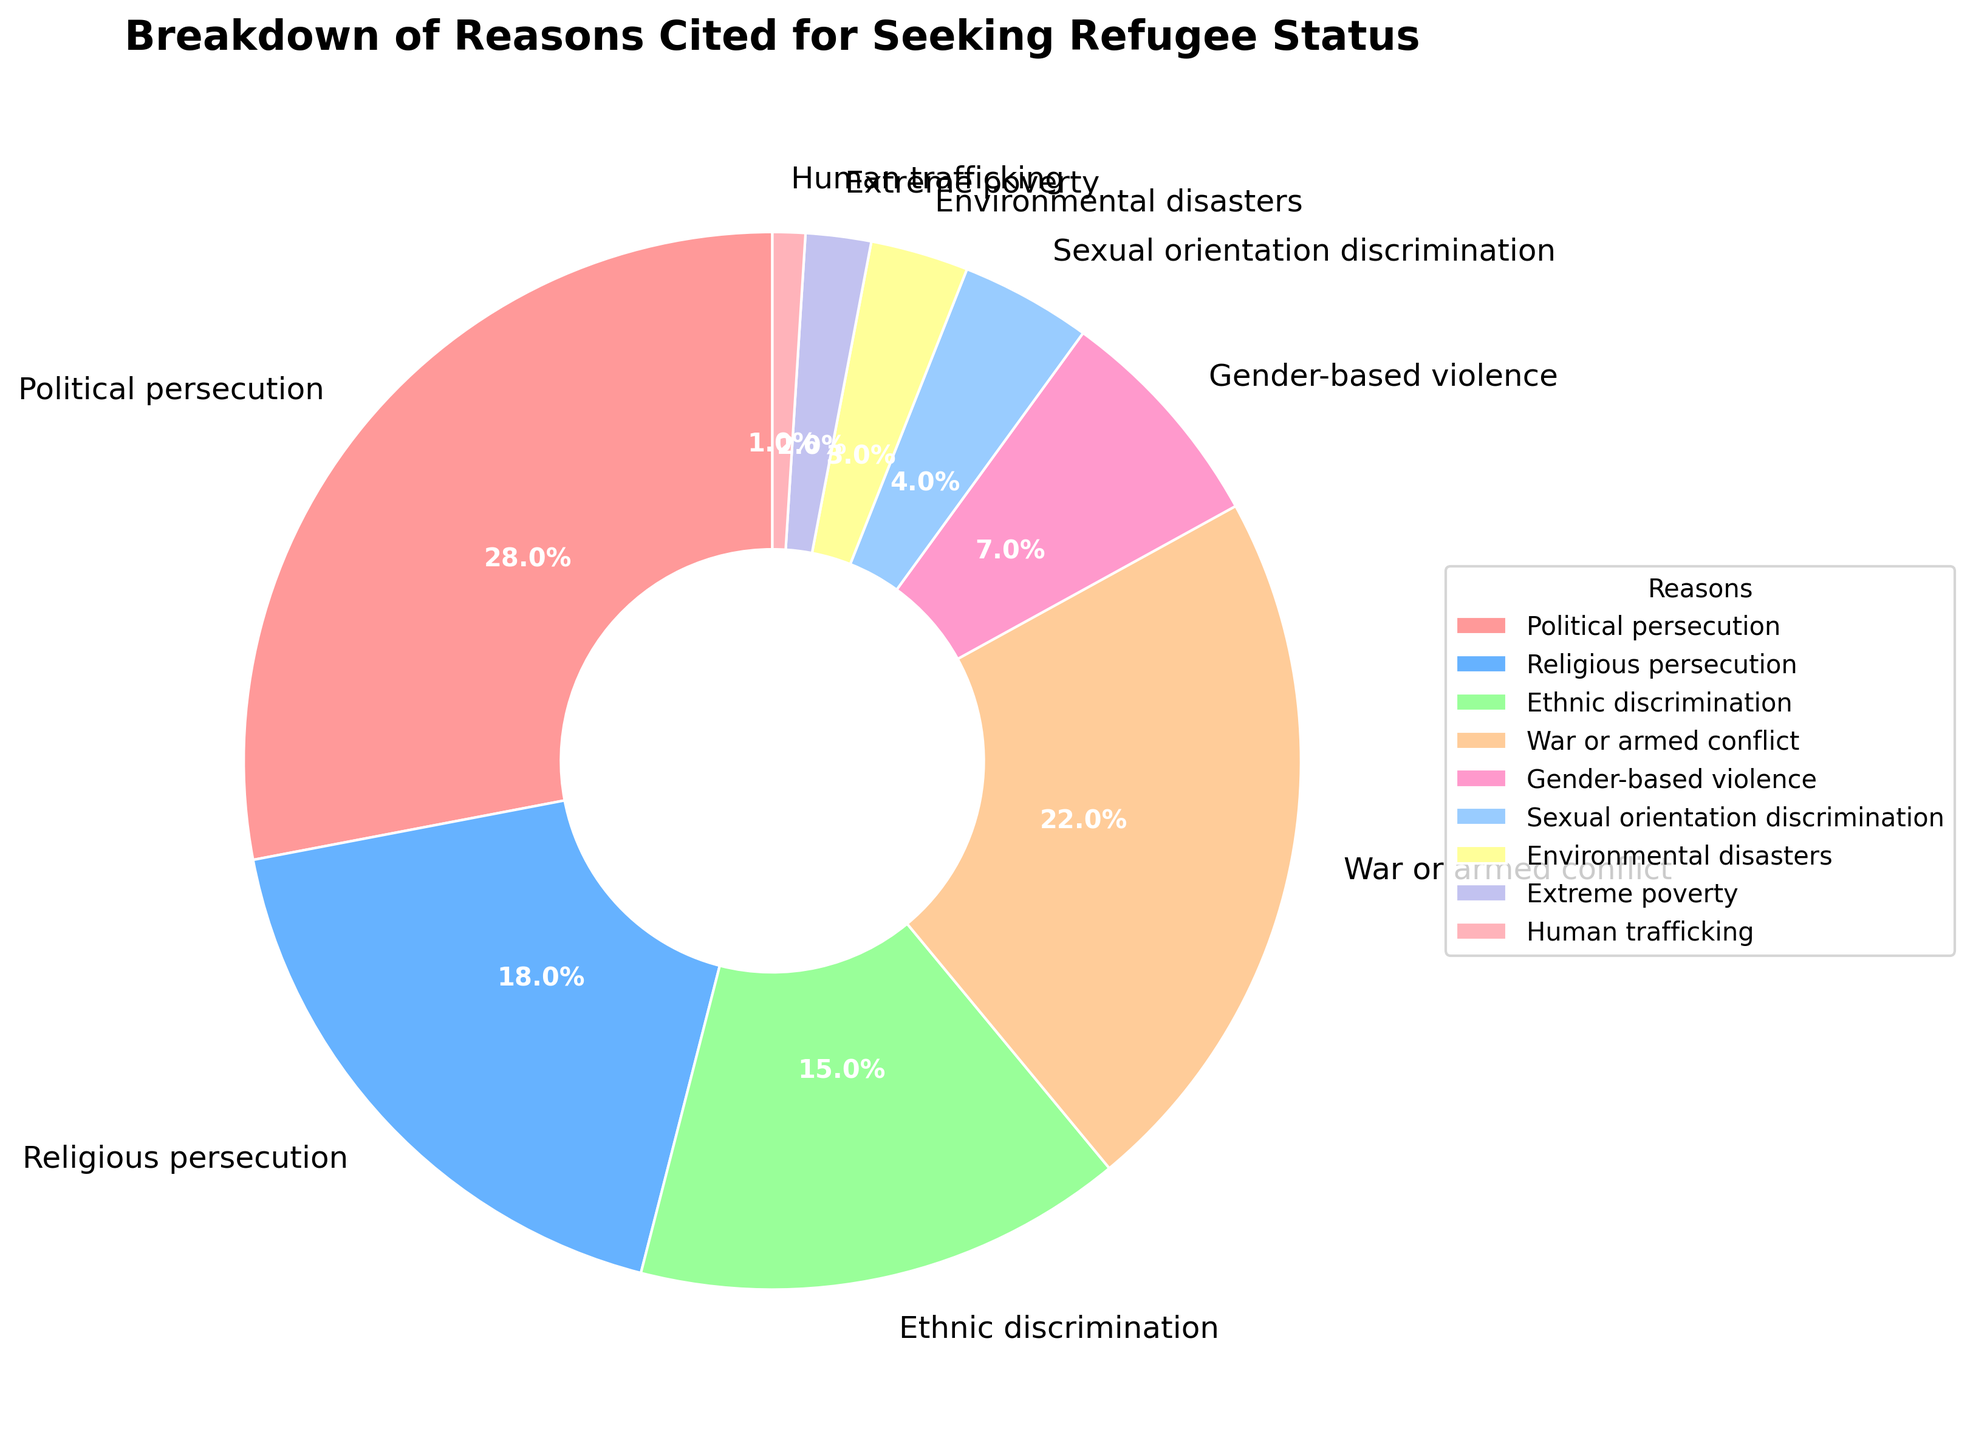Which reason is cited the most for seeking refugee status? From the pie chart, Political persecution has the largest percentage share, accounting for 28%
Answer: Political persecution What percentage of refugees cited war or armed conflict? The pie chart shows that the segment for war or armed conflict is labeled with 22%
Answer: 22% How does the percentage for religious persecution compare to ethnic discrimination? According to the pie chart, religious persecution accounts for 18%, which is higher than ethnic discrimination at 15%
Answer: Religious persecution is higher What is the total percentage for political and religious persecution combined? Summing up the percentages for political persecution (28%) and religious persecution (18%) gives us 28 + 18 = 46%
Answer: 46% Are there more refugees citing environmental disasters or extreme poverty? From the pie chart, environmental disasters account for 3% while extreme poverty accounts for 2%
Answer: Environmental disasters What is the difference in percentage points between gender-based violence and sexual orientation discrimination? The pie chart shows 7% for gender-based violence and 4% for sexual orientation discrimination. The difference is 7 - 4 = 3%
Answer: 3% Which reason has the smallest percentage share, and what is that percentage? From the chart, human trafficking has the smallest segment, labeled as 1%
Answer: Human trafficking, 1% What is the combined percentage for ethnic discrimination, gender-based violence, and human trafficking? Adding the percentages for ethnic discrimination (15%), gender-based violence (7%), and human trafficking (1%) results in 15 + 7 + 1 = 23%
Answer: 23% Compare the visual sizes of the slices for political persecution and war or armed conflict. Which is larger, and by how much percentage-wise? The pie chart illustrates political persecution at 28% and war or armed conflict at 22%. The difference is 28 - 22 = 6%
Answer: Political persecution by 6% How many reasons have a percentage share of less than 10%? Observing the pie chart, the reasons with less than 10% are gender-based violence (7%), sexual orientation discrimination (4%), environmental disasters (3%), extreme poverty (2%), and human trafficking (1%). There are 5 such reasons.
Answer: 5 